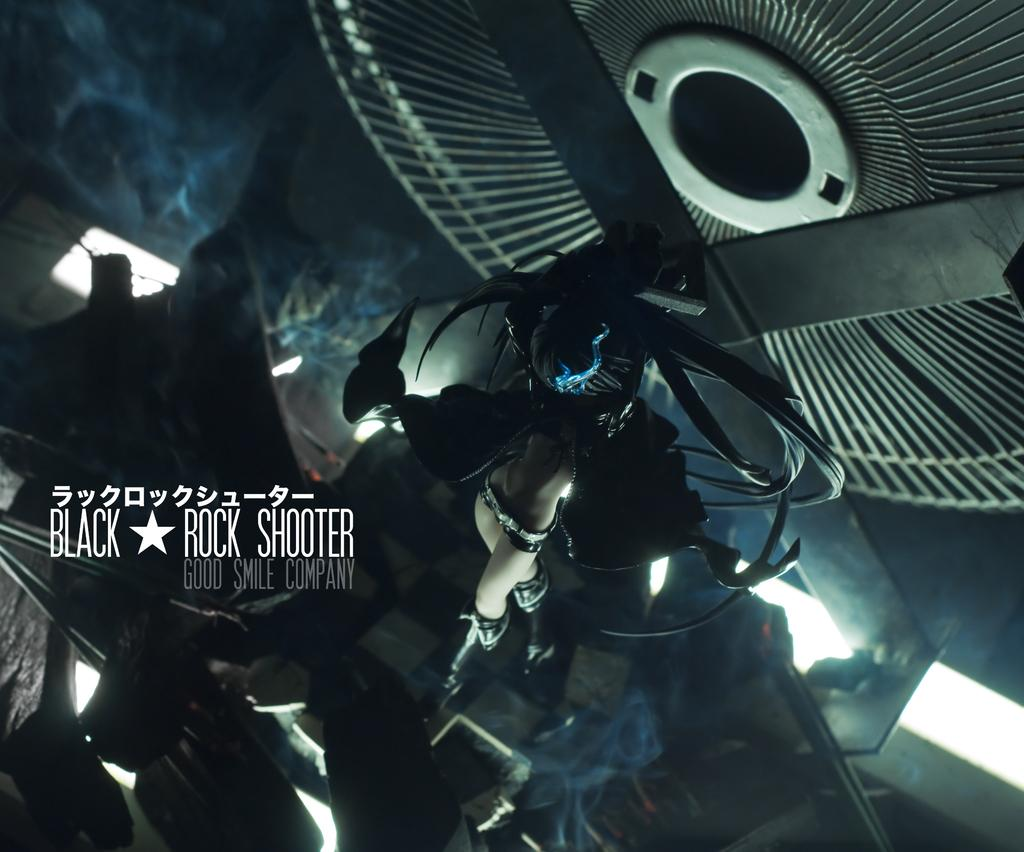<image>
Write a terse but informative summary of the picture. A promotional poster that says Black Rock Shooter. 